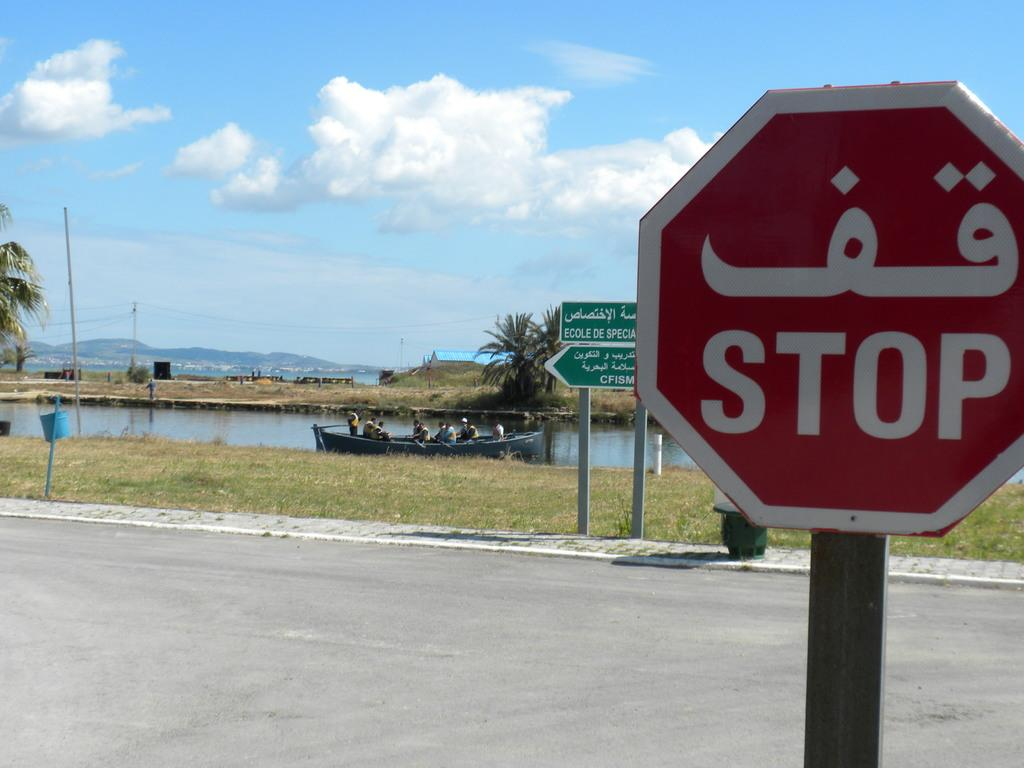<image>
Present a compact description of the photo's key features. A red stop side is on one side of a street as a green street sign is across the street. 